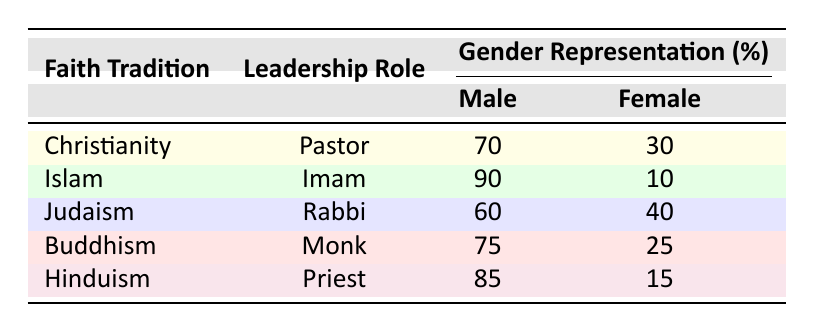What percentage of Buddhist leaders are male? The table shows that for Buddhism, the gender representation for male monks is 75%.
Answer: 75 Which faith tradition has the highest percentage of female leadership in the given roles? By comparing the percentages of female representation across faith traditions, Judaism has the highest percentage with 40%, as all others have less than this.
Answer: Judaism What is the difference in male leadership representation between Islam and Hinduism? The male representation for Islam is 90% and for Hinduism is 85%. The difference is 90% - 85% = 5%.
Answer: 5% Is it true that Christianity has a higher percentage of male leaders than Judaism? For Christianity, the male leader percentage is 70%, while for Judaism it is 60%. Since 70% > 60%, the statement is true.
Answer: Yes What is the average percentage of male leadership across all faith traditions listed? To find the average male representation, add the percentages for males: 70 + 90 + 60 + 75 + 85 = 380. Then divide by the number of faith traditions, which is 5: 380 / 5 = 76.
Answer: 76 Which faith tradition has the lowest representation of female leadership? The percent of female leadership is 30% for Christianity, 10% for Islam, 40% for Judaism, 25% for Buddhism, and 15% for Hinduism. The lowest is 10% for Islam.
Answer: Islam How many leaders in total are represented as male across all the faith traditions? The total percentage of male leaders from each tradition is 70 + 90 + 60 + 75 + 85 = 380%.
Answer: 380 What percentage of leadership roles in Buddhism are held by females? The table indicates that female representation in Buddhism is 25%, as specified for the monk leadership role.
Answer: 25 